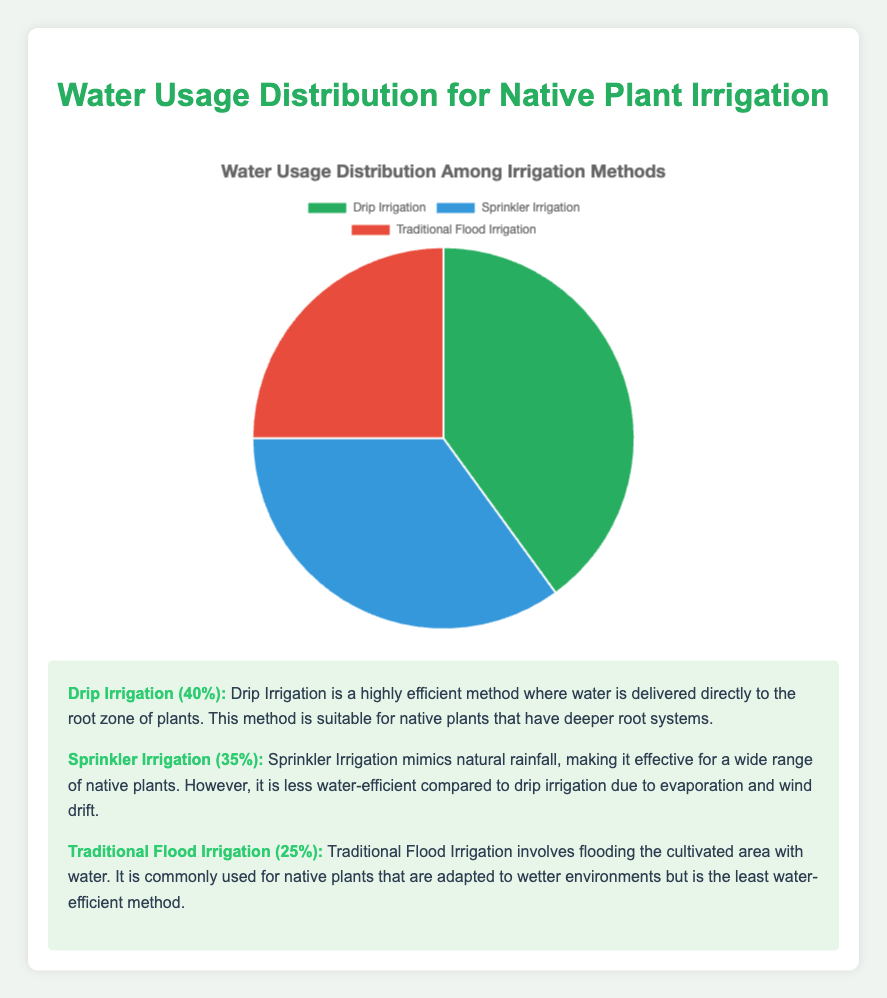How much more water does Drip Irrigation use compared to Traditional Flood Irrigation? Drip Irrigation uses 40% of water, and Traditional Flood Irrigation uses 25%. Subtracting the water usage percentages gives 40% - 25% = 15%.
Answer: 15% What is the total percentage of water usage for both Drip Irrigation and Sprinkler Irrigation combined? Drip Irrigation uses 40% and Sprinkler Irrigation uses 35%. Adding these percentages gives 40% + 35% = 75%.
Answer: 75% Which irrigation method uses the least amount of water? According to the figure, Traditional Flood Irrigation uses 25% of the water, which is the lowest among the three methods.
Answer: Traditional Flood Irrigation By how much does the water usage of Sprinkler Irrigation exceed that of Traditional Flood Irrigation? Sprinkler Irrigation uses 35% of the water while Traditional Flood Irrigation uses 25%. Subtracting these gives 35% - 25% = 10%.
Answer: 10% What percentage of the water usage is utilized by methods other than Drip Irrigation? Drip Irrigation uses 40%, so the remaining water usage is 100% - 40% = 60%.
Answer: 60% Which irrigation method is represented by the red color in the pie chart? In the pie chart, the red color represents Traditional Flood Irrigation.
Answer: Traditional Flood Irrigation Compare the water usage between the most and the least efficient irrigation methods. The most water-efficient method is Drip Irrigation which uses 40%, and the least efficient is Traditional Flood Irrigation which uses 25%. Drip Irrigation uses 15% more water than Traditional Flood Irrigation.
Answer: Drip Irrigation uses 15% more What is the median water usage percentage among the three irrigation methods? The percentages are 40%, 35%, and 25%. Arranging them in ascending order: 25%, 35%, 40%, the median value is the middle number, which is 35%.
Answer: 35% What fraction of the water is used by Sprinkler Irrigation compared to the total usage of both Drip and Traditional Flood Irrigation combined? Drip and Traditional Flood Irrigation combined use 40% + 25% = 65%. Sprinkler Irrigation uses 35%. The fraction is 35% of 65%, or 35/65. Simplifying gives 7/13.
Answer: 7/13 Which irrigation method represented by the green color in the pie chart uses the highest percentage of water? In the pie chart, the green color represents Drip Irrigation, which uses 40% of the water.
Answer: Drip Irrigation 